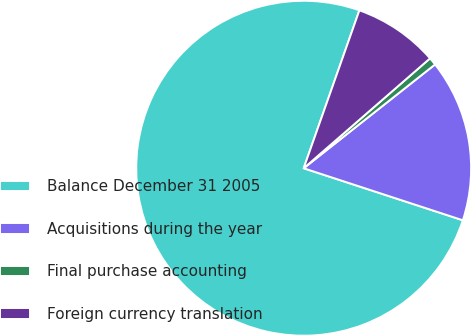Convert chart. <chart><loc_0><loc_0><loc_500><loc_500><pie_chart><fcel>Balance December 31 2005<fcel>Acquisitions during the year<fcel>Final purchase accounting<fcel>Foreign currency translation<nl><fcel>75.37%<fcel>15.67%<fcel>0.75%<fcel>8.21%<nl></chart> 